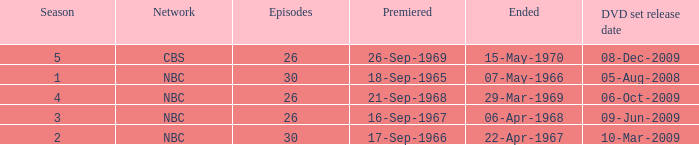What is the total season number for episodes later than episode 30? None. 